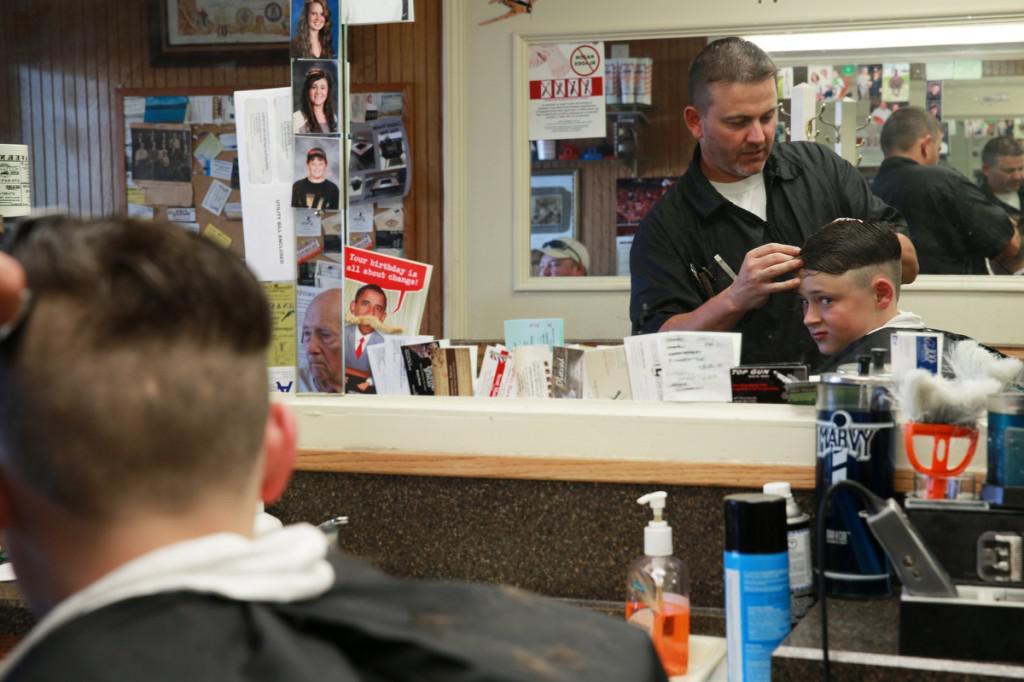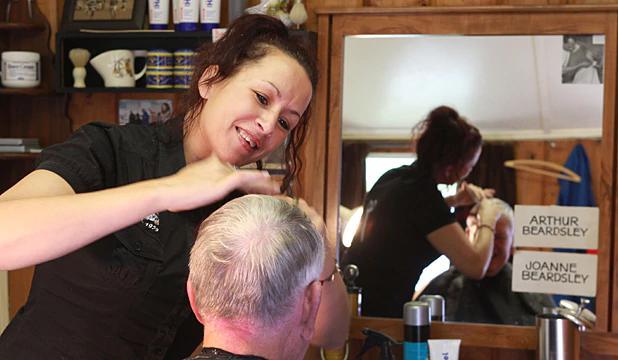The first image is the image on the left, the second image is the image on the right. For the images displayed, is the sentence "An image shows a male barber with eyeglasses behind a customer, working on hair." factually correct? Answer yes or no. No. The first image is the image on the left, the second image is the image on the right. Examine the images to the left and right. Is the description "The male barber in the image on the right is wearing glasses." accurate? Answer yes or no. No. 